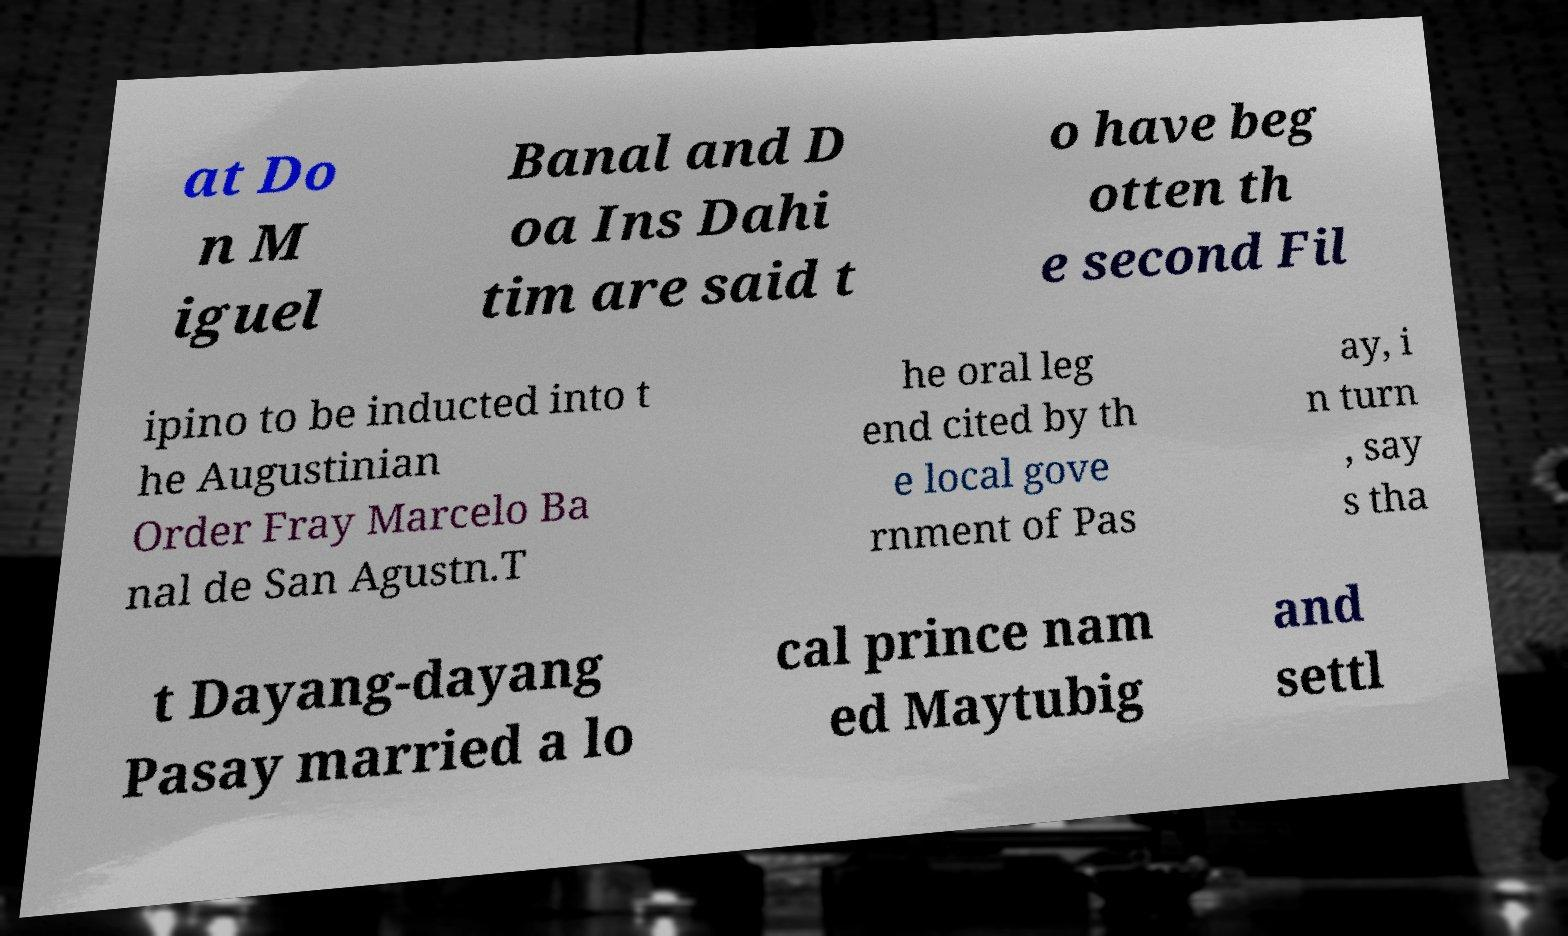There's text embedded in this image that I need extracted. Can you transcribe it verbatim? at Do n M iguel Banal and D oa Ins Dahi tim are said t o have beg otten th e second Fil ipino to be inducted into t he Augustinian Order Fray Marcelo Ba nal de San Agustn.T he oral leg end cited by th e local gove rnment of Pas ay, i n turn , say s tha t Dayang-dayang Pasay married a lo cal prince nam ed Maytubig and settl 